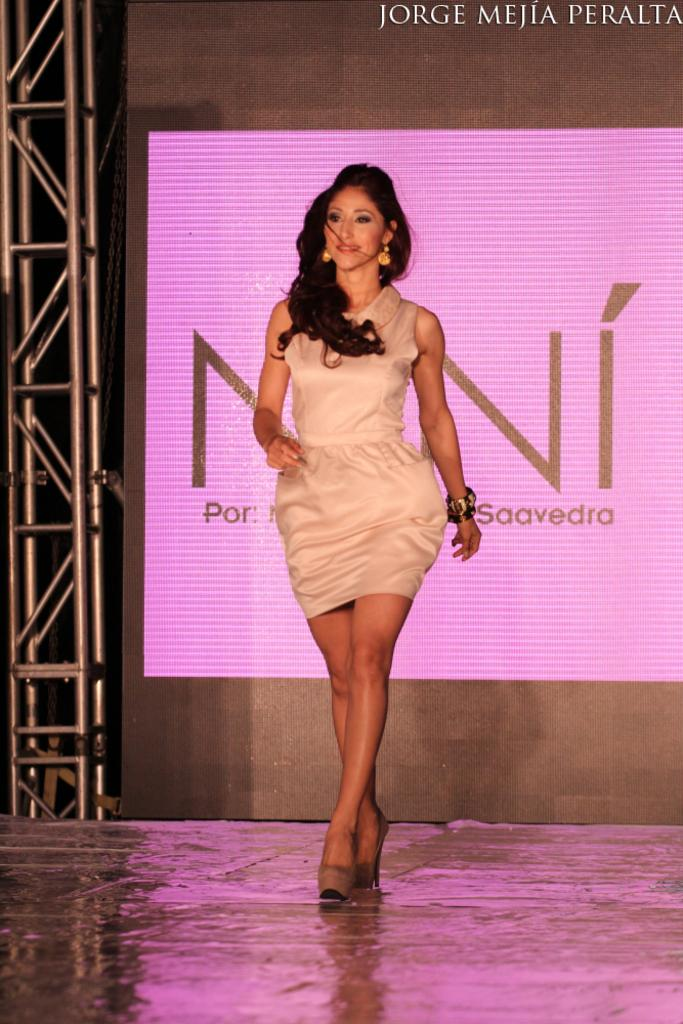What is the main subject of the image? The main subject of the image is a woman standing. What is located behind the woman in the image? There is a projector screen behind the woman. What type of flag is being waved by the bushes in the image? There are no bushes or flags present in the image; it features a woman standing with a projector screen behind her. 